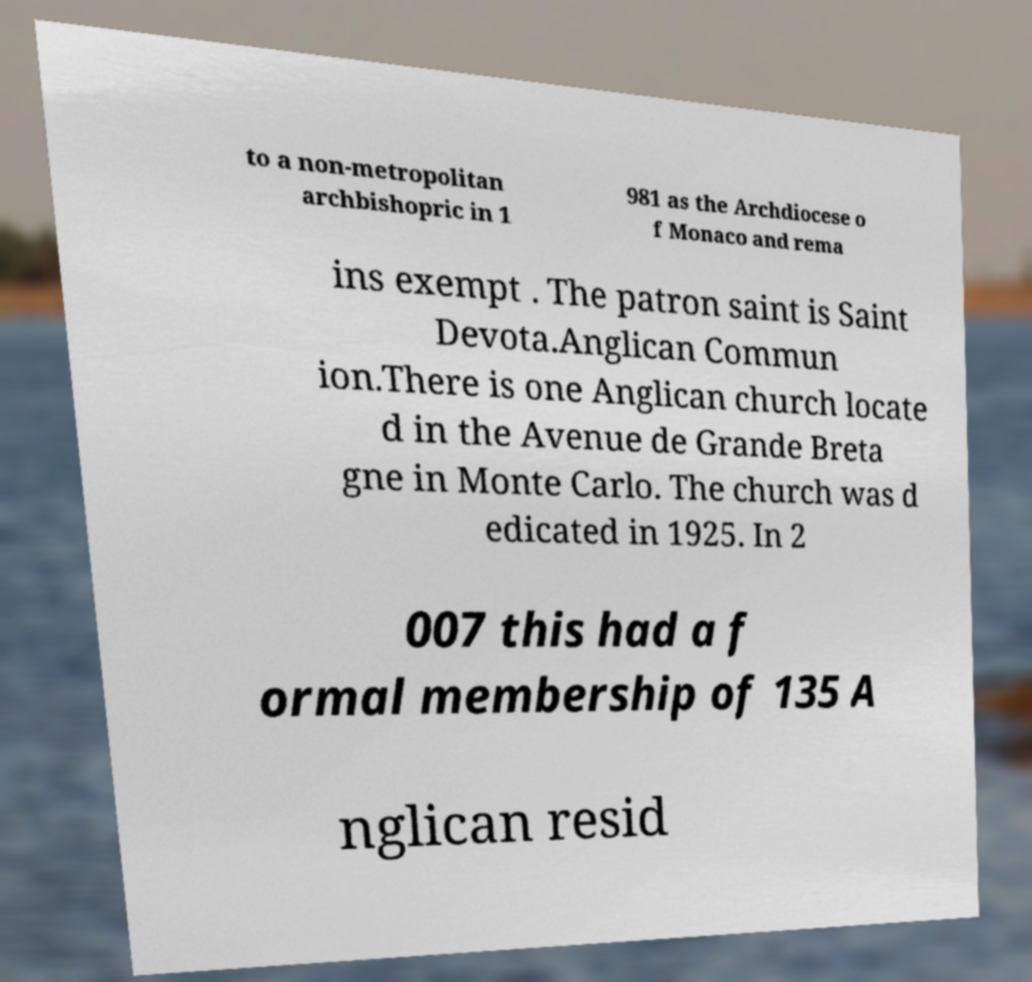Could you assist in decoding the text presented in this image and type it out clearly? to a non-metropolitan archbishopric in 1 981 as the Archdiocese o f Monaco and rema ins exempt . The patron saint is Saint Devota.Anglican Commun ion.There is one Anglican church locate d in the Avenue de Grande Breta gne in Monte Carlo. The church was d edicated in 1925. In 2 007 this had a f ormal membership of 135 A nglican resid 